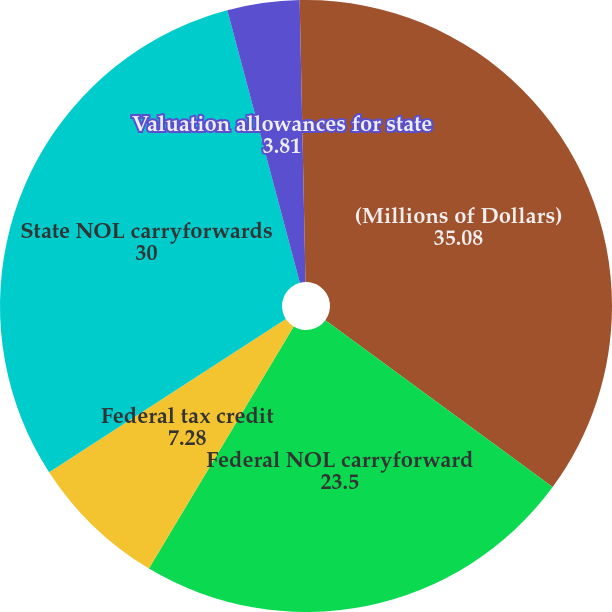<chart> <loc_0><loc_0><loc_500><loc_500><pie_chart><fcel>(Millions of Dollars)<fcel>Federal NOL carryforward<fcel>Federal tax credit<fcel>State NOL carryforwards<fcel>Valuation allowances for state<fcel>State tax credit carryforwards<nl><fcel>35.08%<fcel>23.5%<fcel>7.28%<fcel>30.0%<fcel>3.81%<fcel>0.33%<nl></chart> 